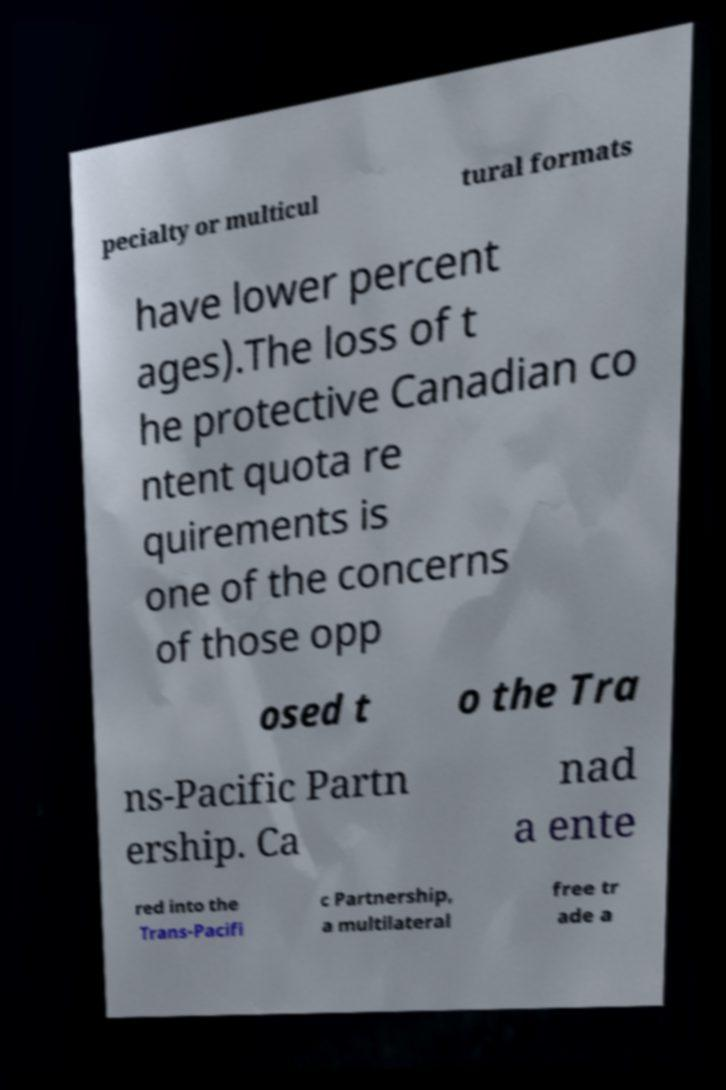I need the written content from this picture converted into text. Can you do that? pecialty or multicul tural formats have lower percent ages).The loss of t he protective Canadian co ntent quota re quirements is one of the concerns of those opp osed t o the Tra ns-Pacific Partn ership. Ca nad a ente red into the Trans-Pacifi c Partnership, a multilateral free tr ade a 